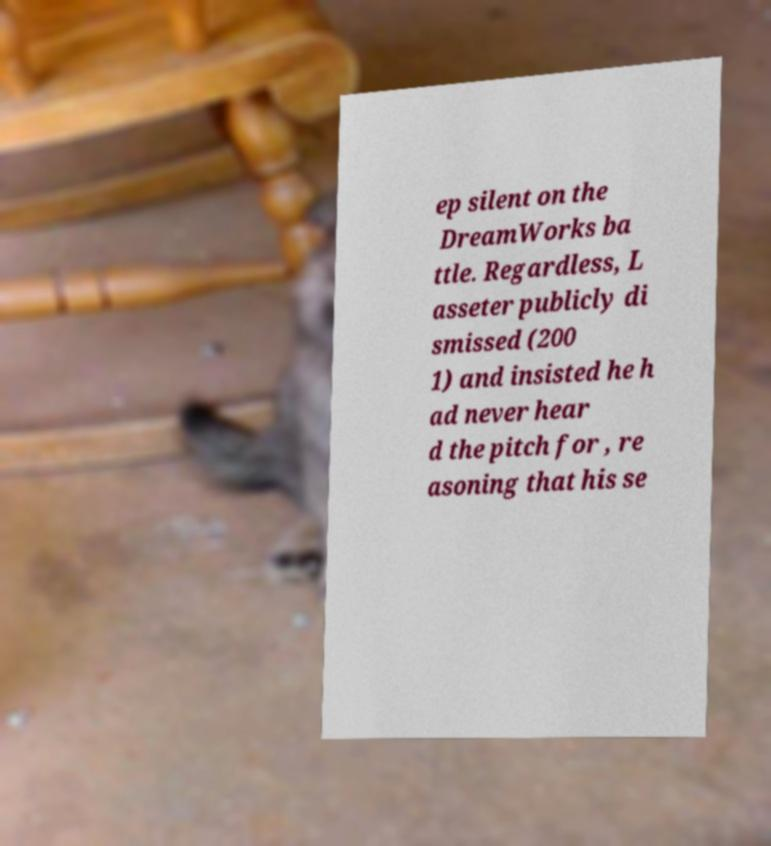Can you read and provide the text displayed in the image?This photo seems to have some interesting text. Can you extract and type it out for me? ep silent on the DreamWorks ba ttle. Regardless, L asseter publicly di smissed (200 1) and insisted he h ad never hear d the pitch for , re asoning that his se 